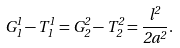Convert formula to latex. <formula><loc_0><loc_0><loc_500><loc_500>G ^ { 1 } _ { 1 } - T ^ { 1 } _ { 1 } = G ^ { 2 } _ { 2 } - T ^ { 2 } _ { 2 } = \frac { l ^ { 2 } } { 2 a ^ { 2 } } .</formula> 